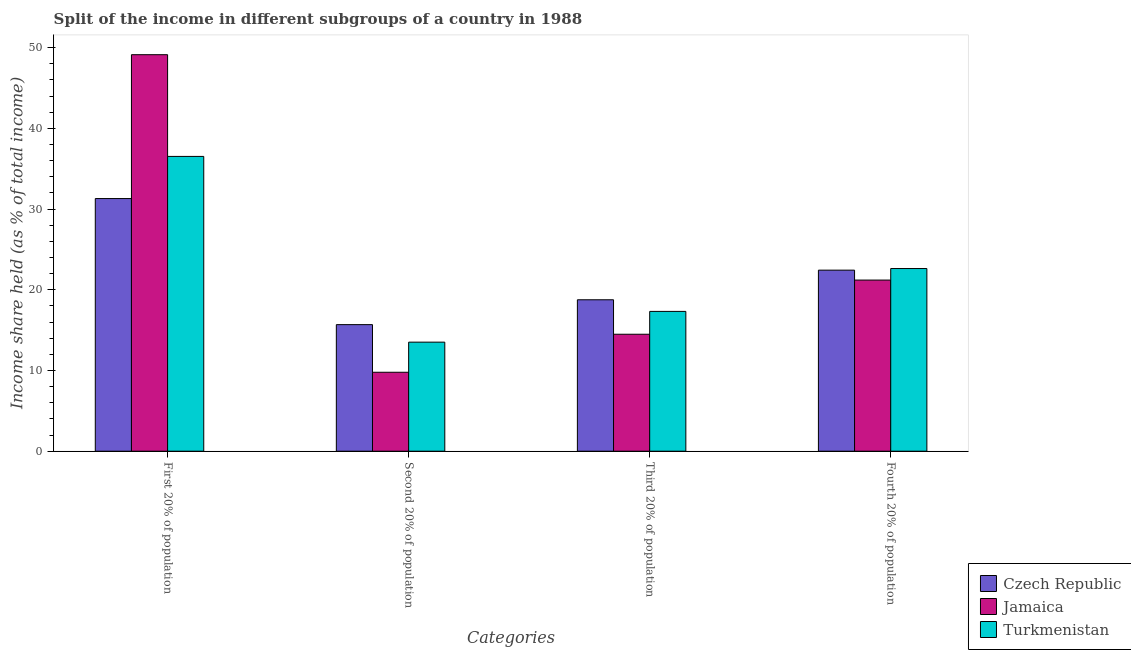How many different coloured bars are there?
Offer a terse response. 3. Are the number of bars per tick equal to the number of legend labels?
Provide a short and direct response. Yes. Are the number of bars on each tick of the X-axis equal?
Make the answer very short. Yes. How many bars are there on the 4th tick from the left?
Ensure brevity in your answer.  3. What is the label of the 2nd group of bars from the left?
Your response must be concise. Second 20% of population. What is the share of the income held by second 20% of the population in Turkmenistan?
Provide a short and direct response. 13.51. Across all countries, what is the maximum share of the income held by first 20% of the population?
Give a very brief answer. 49.12. Across all countries, what is the minimum share of the income held by fourth 20% of the population?
Make the answer very short. 21.2. In which country was the share of the income held by second 20% of the population maximum?
Your response must be concise. Czech Republic. In which country was the share of the income held by third 20% of the population minimum?
Your answer should be compact. Jamaica. What is the total share of the income held by fourth 20% of the population in the graph?
Provide a short and direct response. 66.26. What is the difference between the share of the income held by first 20% of the population in Jamaica and that in Turkmenistan?
Provide a succinct answer. 12.6. What is the difference between the share of the income held by third 20% of the population in Turkmenistan and the share of the income held by second 20% of the population in Jamaica?
Provide a succinct answer. 7.54. What is the average share of the income held by second 20% of the population per country?
Keep it short and to the point. 12.99. What is the difference between the share of the income held by second 20% of the population and share of the income held by first 20% of the population in Jamaica?
Offer a terse response. -39.34. In how many countries, is the share of the income held by second 20% of the population greater than 10 %?
Ensure brevity in your answer.  2. What is the ratio of the share of the income held by first 20% of the population in Czech Republic to that in Turkmenistan?
Your answer should be very brief. 0.86. Is the difference between the share of the income held by first 20% of the population in Czech Republic and Jamaica greater than the difference between the share of the income held by third 20% of the population in Czech Republic and Jamaica?
Provide a short and direct response. No. What is the difference between the highest and the second highest share of the income held by third 20% of the population?
Your response must be concise. 1.44. What is the difference between the highest and the lowest share of the income held by second 20% of the population?
Ensure brevity in your answer.  5.9. Is the sum of the share of the income held by fourth 20% of the population in Czech Republic and Turkmenistan greater than the maximum share of the income held by third 20% of the population across all countries?
Give a very brief answer. Yes. Is it the case that in every country, the sum of the share of the income held by third 20% of the population and share of the income held by fourth 20% of the population is greater than the sum of share of the income held by first 20% of the population and share of the income held by second 20% of the population?
Your answer should be very brief. Yes. What does the 1st bar from the left in First 20% of population represents?
Your answer should be very brief. Czech Republic. What does the 2nd bar from the right in Fourth 20% of population represents?
Your answer should be compact. Jamaica. Is it the case that in every country, the sum of the share of the income held by first 20% of the population and share of the income held by second 20% of the population is greater than the share of the income held by third 20% of the population?
Provide a short and direct response. Yes. Are all the bars in the graph horizontal?
Give a very brief answer. No. Are the values on the major ticks of Y-axis written in scientific E-notation?
Offer a very short reply. No. Does the graph contain grids?
Ensure brevity in your answer.  No. How are the legend labels stacked?
Your response must be concise. Vertical. What is the title of the graph?
Make the answer very short. Split of the income in different subgroups of a country in 1988. Does "Yemen, Rep." appear as one of the legend labels in the graph?
Your answer should be very brief. No. What is the label or title of the X-axis?
Make the answer very short. Categories. What is the label or title of the Y-axis?
Provide a short and direct response. Income share held (as % of total income). What is the Income share held (as % of total income) of Czech Republic in First 20% of population?
Provide a short and direct response. 31.3. What is the Income share held (as % of total income) in Jamaica in First 20% of population?
Offer a terse response. 49.12. What is the Income share held (as % of total income) of Turkmenistan in First 20% of population?
Provide a succinct answer. 36.52. What is the Income share held (as % of total income) of Czech Republic in Second 20% of population?
Provide a succinct answer. 15.68. What is the Income share held (as % of total income) in Jamaica in Second 20% of population?
Keep it short and to the point. 9.78. What is the Income share held (as % of total income) of Turkmenistan in Second 20% of population?
Offer a very short reply. 13.51. What is the Income share held (as % of total income) of Czech Republic in Third 20% of population?
Provide a short and direct response. 18.76. What is the Income share held (as % of total income) of Jamaica in Third 20% of population?
Provide a succinct answer. 14.49. What is the Income share held (as % of total income) in Turkmenistan in Third 20% of population?
Ensure brevity in your answer.  17.32. What is the Income share held (as % of total income) in Czech Republic in Fourth 20% of population?
Give a very brief answer. 22.43. What is the Income share held (as % of total income) in Jamaica in Fourth 20% of population?
Offer a very short reply. 21.2. What is the Income share held (as % of total income) in Turkmenistan in Fourth 20% of population?
Offer a terse response. 22.63. Across all Categories, what is the maximum Income share held (as % of total income) in Czech Republic?
Provide a succinct answer. 31.3. Across all Categories, what is the maximum Income share held (as % of total income) in Jamaica?
Your answer should be compact. 49.12. Across all Categories, what is the maximum Income share held (as % of total income) of Turkmenistan?
Your response must be concise. 36.52. Across all Categories, what is the minimum Income share held (as % of total income) of Czech Republic?
Provide a succinct answer. 15.68. Across all Categories, what is the minimum Income share held (as % of total income) in Jamaica?
Give a very brief answer. 9.78. Across all Categories, what is the minimum Income share held (as % of total income) in Turkmenistan?
Your answer should be compact. 13.51. What is the total Income share held (as % of total income) of Czech Republic in the graph?
Your response must be concise. 88.17. What is the total Income share held (as % of total income) of Jamaica in the graph?
Keep it short and to the point. 94.59. What is the total Income share held (as % of total income) of Turkmenistan in the graph?
Provide a succinct answer. 89.98. What is the difference between the Income share held (as % of total income) of Czech Republic in First 20% of population and that in Second 20% of population?
Your answer should be very brief. 15.62. What is the difference between the Income share held (as % of total income) of Jamaica in First 20% of population and that in Second 20% of population?
Provide a short and direct response. 39.34. What is the difference between the Income share held (as % of total income) in Turkmenistan in First 20% of population and that in Second 20% of population?
Provide a succinct answer. 23.01. What is the difference between the Income share held (as % of total income) in Czech Republic in First 20% of population and that in Third 20% of population?
Your response must be concise. 12.54. What is the difference between the Income share held (as % of total income) of Jamaica in First 20% of population and that in Third 20% of population?
Your answer should be very brief. 34.63. What is the difference between the Income share held (as % of total income) of Czech Republic in First 20% of population and that in Fourth 20% of population?
Provide a succinct answer. 8.87. What is the difference between the Income share held (as % of total income) of Jamaica in First 20% of population and that in Fourth 20% of population?
Your answer should be very brief. 27.92. What is the difference between the Income share held (as % of total income) in Turkmenistan in First 20% of population and that in Fourth 20% of population?
Provide a succinct answer. 13.89. What is the difference between the Income share held (as % of total income) of Czech Republic in Second 20% of population and that in Third 20% of population?
Ensure brevity in your answer.  -3.08. What is the difference between the Income share held (as % of total income) in Jamaica in Second 20% of population and that in Third 20% of population?
Provide a succinct answer. -4.71. What is the difference between the Income share held (as % of total income) of Turkmenistan in Second 20% of population and that in Third 20% of population?
Your answer should be very brief. -3.81. What is the difference between the Income share held (as % of total income) in Czech Republic in Second 20% of population and that in Fourth 20% of population?
Make the answer very short. -6.75. What is the difference between the Income share held (as % of total income) in Jamaica in Second 20% of population and that in Fourth 20% of population?
Make the answer very short. -11.42. What is the difference between the Income share held (as % of total income) of Turkmenistan in Second 20% of population and that in Fourth 20% of population?
Your answer should be compact. -9.12. What is the difference between the Income share held (as % of total income) of Czech Republic in Third 20% of population and that in Fourth 20% of population?
Your response must be concise. -3.67. What is the difference between the Income share held (as % of total income) of Jamaica in Third 20% of population and that in Fourth 20% of population?
Offer a very short reply. -6.71. What is the difference between the Income share held (as % of total income) in Turkmenistan in Third 20% of population and that in Fourth 20% of population?
Your answer should be compact. -5.31. What is the difference between the Income share held (as % of total income) in Czech Republic in First 20% of population and the Income share held (as % of total income) in Jamaica in Second 20% of population?
Provide a succinct answer. 21.52. What is the difference between the Income share held (as % of total income) of Czech Republic in First 20% of population and the Income share held (as % of total income) of Turkmenistan in Second 20% of population?
Offer a very short reply. 17.79. What is the difference between the Income share held (as % of total income) of Jamaica in First 20% of population and the Income share held (as % of total income) of Turkmenistan in Second 20% of population?
Provide a succinct answer. 35.61. What is the difference between the Income share held (as % of total income) in Czech Republic in First 20% of population and the Income share held (as % of total income) in Jamaica in Third 20% of population?
Provide a succinct answer. 16.81. What is the difference between the Income share held (as % of total income) in Czech Republic in First 20% of population and the Income share held (as % of total income) in Turkmenistan in Third 20% of population?
Make the answer very short. 13.98. What is the difference between the Income share held (as % of total income) in Jamaica in First 20% of population and the Income share held (as % of total income) in Turkmenistan in Third 20% of population?
Make the answer very short. 31.8. What is the difference between the Income share held (as % of total income) of Czech Republic in First 20% of population and the Income share held (as % of total income) of Jamaica in Fourth 20% of population?
Provide a short and direct response. 10.1. What is the difference between the Income share held (as % of total income) of Czech Republic in First 20% of population and the Income share held (as % of total income) of Turkmenistan in Fourth 20% of population?
Your response must be concise. 8.67. What is the difference between the Income share held (as % of total income) in Jamaica in First 20% of population and the Income share held (as % of total income) in Turkmenistan in Fourth 20% of population?
Offer a terse response. 26.49. What is the difference between the Income share held (as % of total income) of Czech Republic in Second 20% of population and the Income share held (as % of total income) of Jamaica in Third 20% of population?
Your answer should be very brief. 1.19. What is the difference between the Income share held (as % of total income) in Czech Republic in Second 20% of population and the Income share held (as % of total income) in Turkmenistan in Third 20% of population?
Offer a very short reply. -1.64. What is the difference between the Income share held (as % of total income) of Jamaica in Second 20% of population and the Income share held (as % of total income) of Turkmenistan in Third 20% of population?
Provide a succinct answer. -7.54. What is the difference between the Income share held (as % of total income) in Czech Republic in Second 20% of population and the Income share held (as % of total income) in Jamaica in Fourth 20% of population?
Ensure brevity in your answer.  -5.52. What is the difference between the Income share held (as % of total income) of Czech Republic in Second 20% of population and the Income share held (as % of total income) of Turkmenistan in Fourth 20% of population?
Offer a very short reply. -6.95. What is the difference between the Income share held (as % of total income) of Jamaica in Second 20% of population and the Income share held (as % of total income) of Turkmenistan in Fourth 20% of population?
Offer a terse response. -12.85. What is the difference between the Income share held (as % of total income) in Czech Republic in Third 20% of population and the Income share held (as % of total income) in Jamaica in Fourth 20% of population?
Your response must be concise. -2.44. What is the difference between the Income share held (as % of total income) of Czech Republic in Third 20% of population and the Income share held (as % of total income) of Turkmenistan in Fourth 20% of population?
Offer a very short reply. -3.87. What is the difference between the Income share held (as % of total income) in Jamaica in Third 20% of population and the Income share held (as % of total income) in Turkmenistan in Fourth 20% of population?
Give a very brief answer. -8.14. What is the average Income share held (as % of total income) of Czech Republic per Categories?
Provide a short and direct response. 22.04. What is the average Income share held (as % of total income) in Jamaica per Categories?
Make the answer very short. 23.65. What is the average Income share held (as % of total income) of Turkmenistan per Categories?
Make the answer very short. 22.5. What is the difference between the Income share held (as % of total income) in Czech Republic and Income share held (as % of total income) in Jamaica in First 20% of population?
Your answer should be very brief. -17.82. What is the difference between the Income share held (as % of total income) of Czech Republic and Income share held (as % of total income) of Turkmenistan in First 20% of population?
Provide a succinct answer. -5.22. What is the difference between the Income share held (as % of total income) of Czech Republic and Income share held (as % of total income) of Turkmenistan in Second 20% of population?
Your answer should be compact. 2.17. What is the difference between the Income share held (as % of total income) in Jamaica and Income share held (as % of total income) in Turkmenistan in Second 20% of population?
Provide a succinct answer. -3.73. What is the difference between the Income share held (as % of total income) of Czech Republic and Income share held (as % of total income) of Jamaica in Third 20% of population?
Ensure brevity in your answer.  4.27. What is the difference between the Income share held (as % of total income) in Czech Republic and Income share held (as % of total income) in Turkmenistan in Third 20% of population?
Ensure brevity in your answer.  1.44. What is the difference between the Income share held (as % of total income) in Jamaica and Income share held (as % of total income) in Turkmenistan in Third 20% of population?
Keep it short and to the point. -2.83. What is the difference between the Income share held (as % of total income) of Czech Republic and Income share held (as % of total income) of Jamaica in Fourth 20% of population?
Your answer should be very brief. 1.23. What is the difference between the Income share held (as % of total income) in Jamaica and Income share held (as % of total income) in Turkmenistan in Fourth 20% of population?
Your answer should be very brief. -1.43. What is the ratio of the Income share held (as % of total income) in Czech Republic in First 20% of population to that in Second 20% of population?
Provide a succinct answer. 2. What is the ratio of the Income share held (as % of total income) in Jamaica in First 20% of population to that in Second 20% of population?
Provide a short and direct response. 5.02. What is the ratio of the Income share held (as % of total income) of Turkmenistan in First 20% of population to that in Second 20% of population?
Keep it short and to the point. 2.7. What is the ratio of the Income share held (as % of total income) in Czech Republic in First 20% of population to that in Third 20% of population?
Your answer should be very brief. 1.67. What is the ratio of the Income share held (as % of total income) in Jamaica in First 20% of population to that in Third 20% of population?
Your answer should be very brief. 3.39. What is the ratio of the Income share held (as % of total income) in Turkmenistan in First 20% of population to that in Third 20% of population?
Offer a very short reply. 2.11. What is the ratio of the Income share held (as % of total income) of Czech Republic in First 20% of population to that in Fourth 20% of population?
Provide a succinct answer. 1.4. What is the ratio of the Income share held (as % of total income) in Jamaica in First 20% of population to that in Fourth 20% of population?
Your response must be concise. 2.32. What is the ratio of the Income share held (as % of total income) of Turkmenistan in First 20% of population to that in Fourth 20% of population?
Provide a succinct answer. 1.61. What is the ratio of the Income share held (as % of total income) in Czech Republic in Second 20% of population to that in Third 20% of population?
Keep it short and to the point. 0.84. What is the ratio of the Income share held (as % of total income) of Jamaica in Second 20% of population to that in Third 20% of population?
Your answer should be compact. 0.67. What is the ratio of the Income share held (as % of total income) in Turkmenistan in Second 20% of population to that in Third 20% of population?
Provide a succinct answer. 0.78. What is the ratio of the Income share held (as % of total income) in Czech Republic in Second 20% of population to that in Fourth 20% of population?
Provide a succinct answer. 0.7. What is the ratio of the Income share held (as % of total income) of Jamaica in Second 20% of population to that in Fourth 20% of population?
Keep it short and to the point. 0.46. What is the ratio of the Income share held (as % of total income) in Turkmenistan in Second 20% of population to that in Fourth 20% of population?
Offer a terse response. 0.6. What is the ratio of the Income share held (as % of total income) of Czech Republic in Third 20% of population to that in Fourth 20% of population?
Offer a very short reply. 0.84. What is the ratio of the Income share held (as % of total income) in Jamaica in Third 20% of population to that in Fourth 20% of population?
Your response must be concise. 0.68. What is the ratio of the Income share held (as % of total income) of Turkmenistan in Third 20% of population to that in Fourth 20% of population?
Keep it short and to the point. 0.77. What is the difference between the highest and the second highest Income share held (as % of total income) of Czech Republic?
Make the answer very short. 8.87. What is the difference between the highest and the second highest Income share held (as % of total income) in Jamaica?
Give a very brief answer. 27.92. What is the difference between the highest and the second highest Income share held (as % of total income) of Turkmenistan?
Give a very brief answer. 13.89. What is the difference between the highest and the lowest Income share held (as % of total income) of Czech Republic?
Give a very brief answer. 15.62. What is the difference between the highest and the lowest Income share held (as % of total income) in Jamaica?
Your answer should be very brief. 39.34. What is the difference between the highest and the lowest Income share held (as % of total income) in Turkmenistan?
Provide a short and direct response. 23.01. 